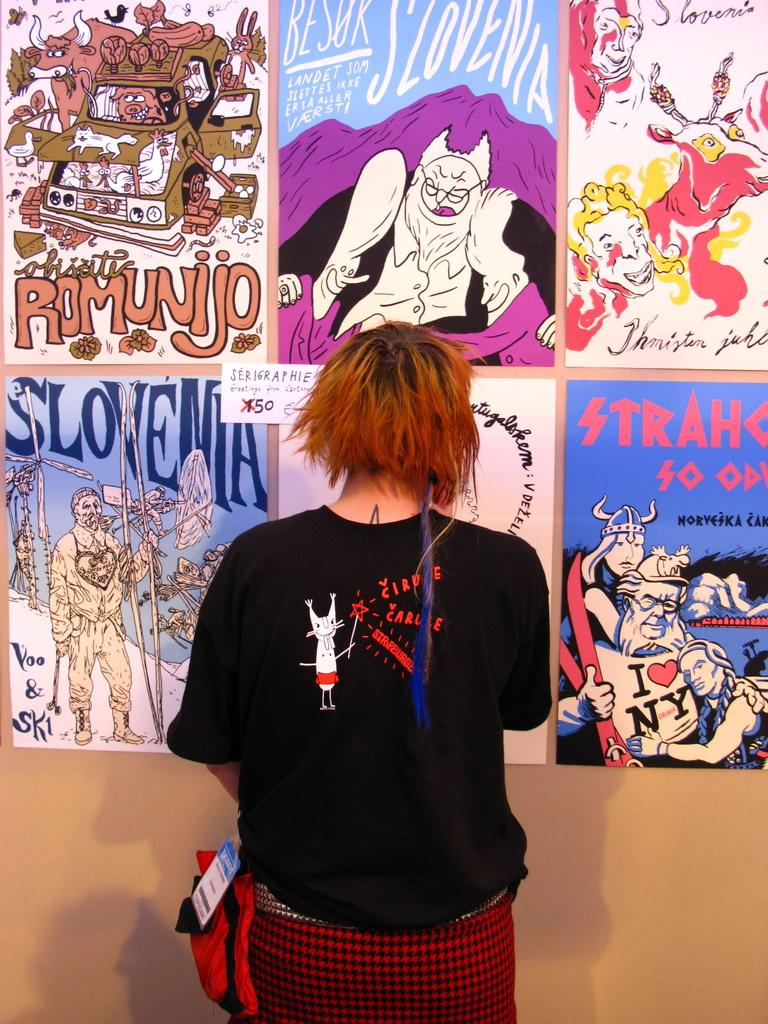Provide a one-sentence caption for the provided image. woman in black shirt with red hair standing in front of posters for slovenia, romunijo and others. 